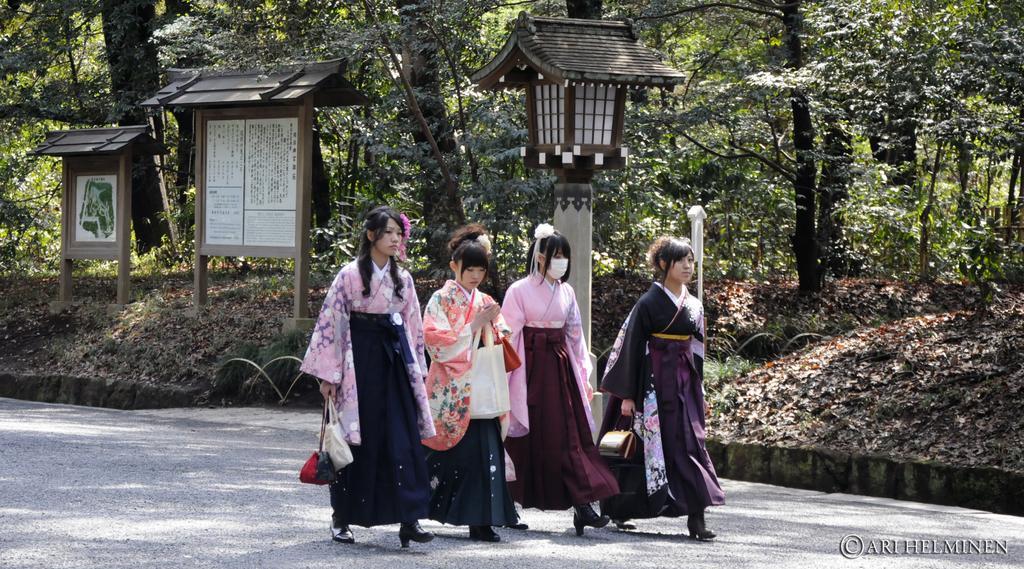Please provide a concise description of this image. In this picture we can see few women are walking on the road, few people are holding bags, in the background we can find few sign boards and trees. 